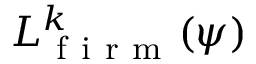<formula> <loc_0><loc_0><loc_500><loc_500>L _ { f i r m } ^ { k } ( \psi )</formula> 